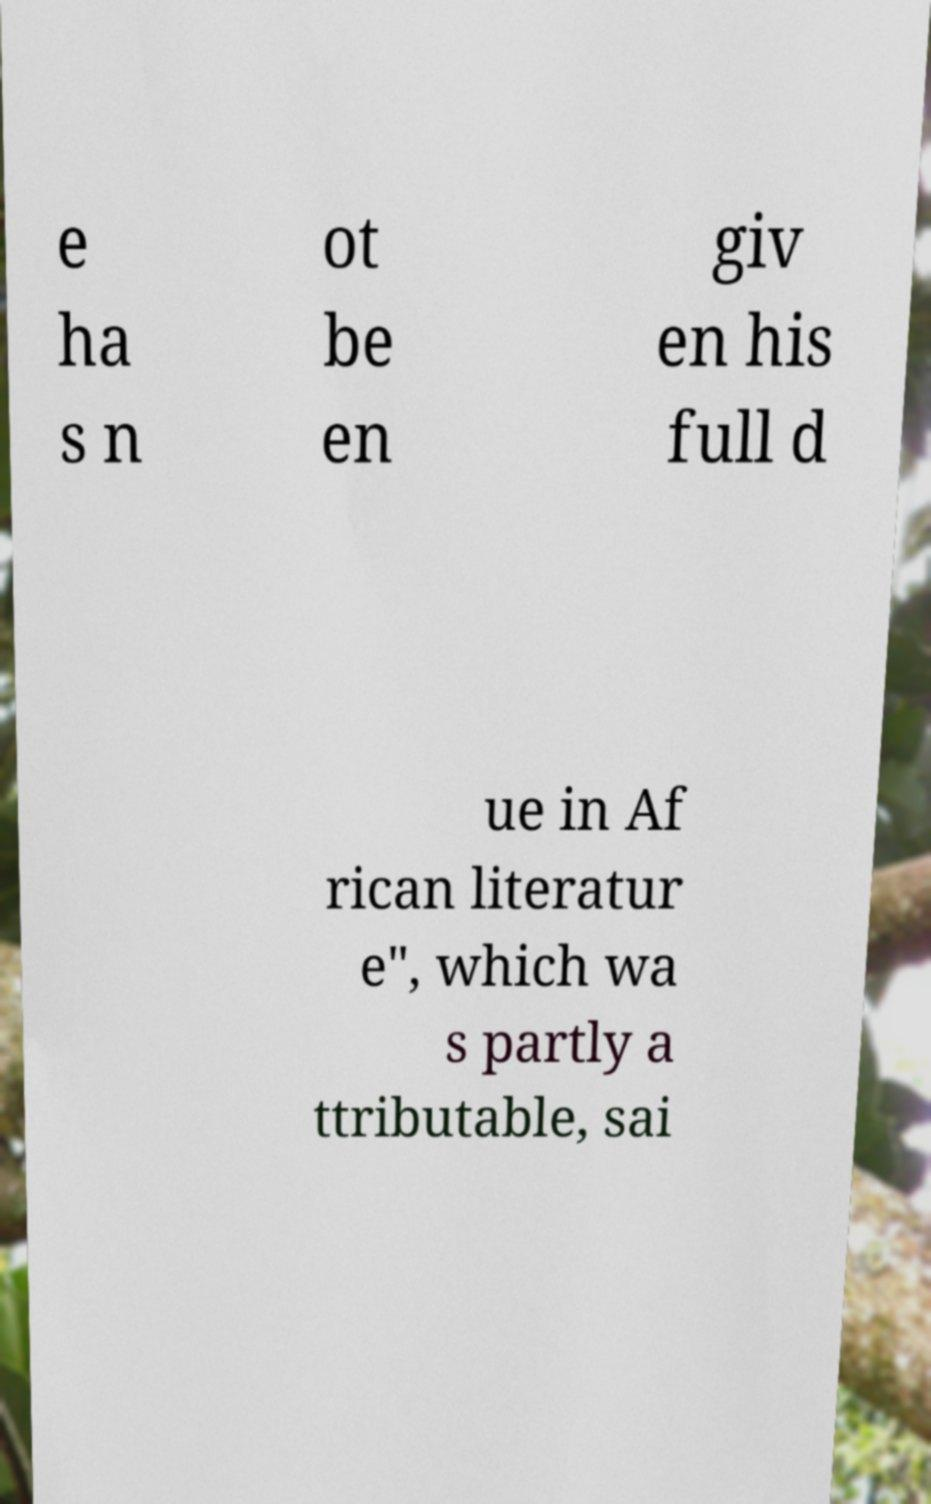There's text embedded in this image that I need extracted. Can you transcribe it verbatim? e ha s n ot be en giv en his full d ue in Af rican literatur e", which wa s partly a ttributable, sai 